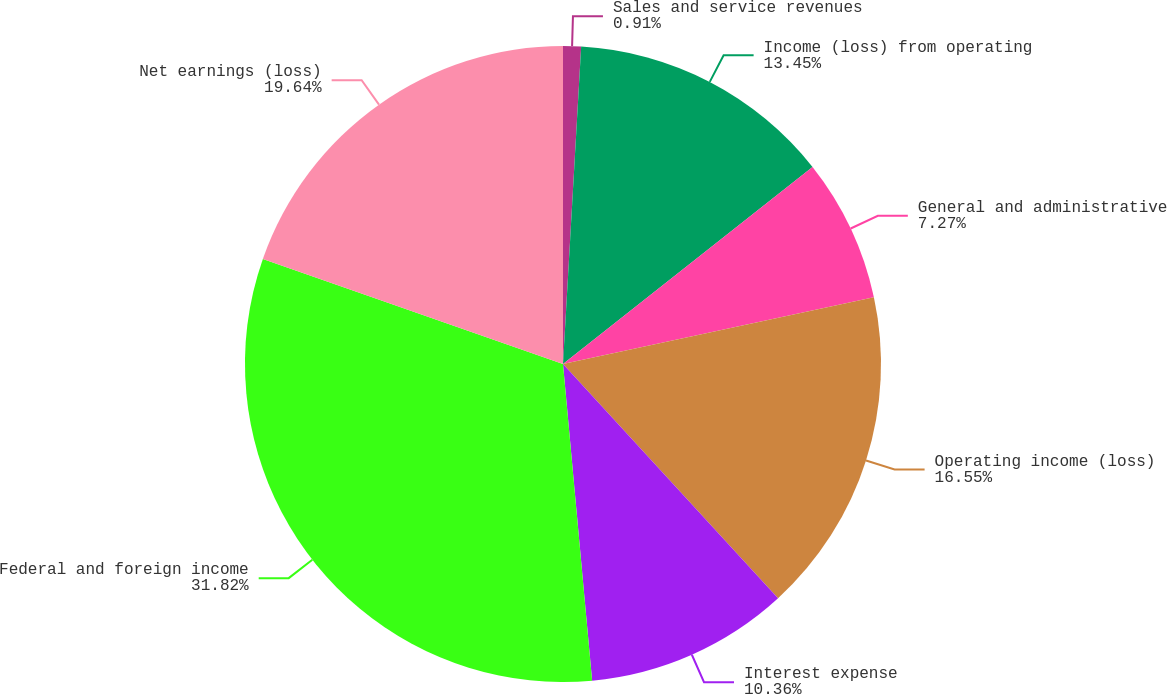Convert chart. <chart><loc_0><loc_0><loc_500><loc_500><pie_chart><fcel>Sales and service revenues<fcel>Income (loss) from operating<fcel>General and administrative<fcel>Operating income (loss)<fcel>Interest expense<fcel>Federal and foreign income<fcel>Net earnings (loss)<nl><fcel>0.91%<fcel>13.45%<fcel>7.27%<fcel>16.55%<fcel>10.36%<fcel>31.82%<fcel>19.64%<nl></chart> 